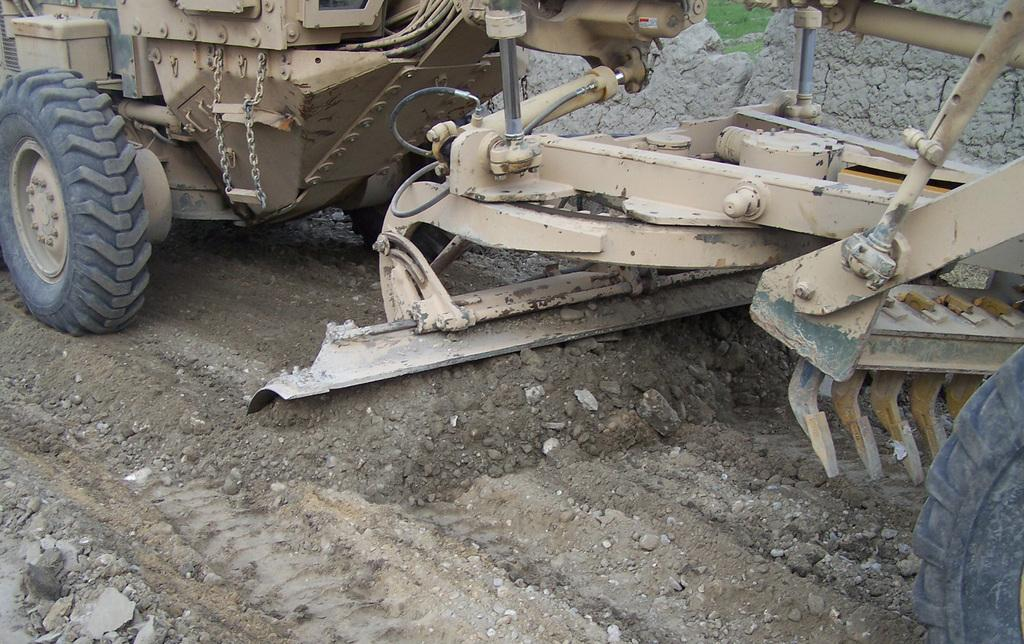What type of construction vehicle is in the image? There is a digging vehicle in the image. What is the digging vehicle doing in the image? The digging vehicle is likely being used to move or dig up soil. Can you describe the environment in the image? The image shows soil, which suggests that the digging vehicle is being used in an outdoor or construction site setting. What list of items is being carried by the construction vehicle in the image? There is no list of items visible in the image; the construction vehicle is focused on digging or moving soil. 